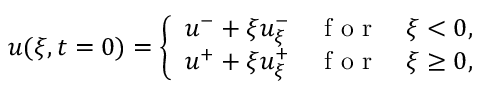<formula> <loc_0><loc_0><loc_500><loc_500>\begin{array} { r } { u ( \xi , t = 0 ) = \left \{ \begin{array} { l l } { u ^ { - } + \xi u _ { \xi } ^ { - } \quad f o r \quad \xi < 0 , } \\ { u ^ { + } + \xi u _ { \xi } ^ { + } \quad f o r \quad \xi \geq 0 , } \end{array} } \end{array}</formula> 